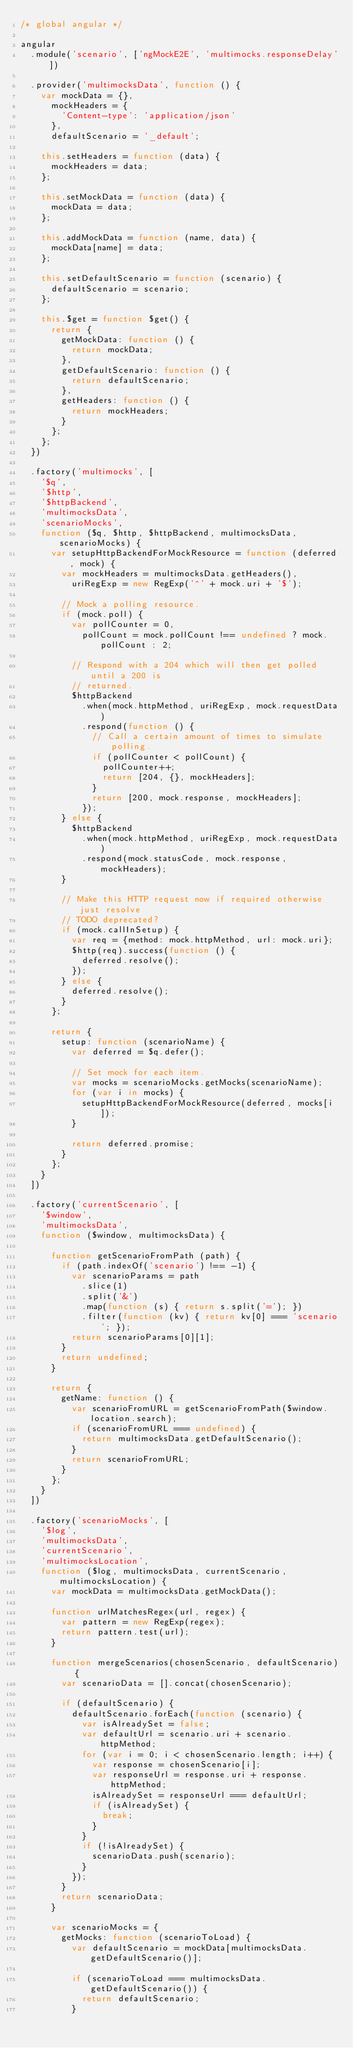<code> <loc_0><loc_0><loc_500><loc_500><_JavaScript_>/* global angular */

angular
  .module('scenario', ['ngMockE2E', 'multimocks.responseDelay'])

  .provider('multimocksData', function () {
    var mockData = {},
      mockHeaders = {
        'Content-type': 'application/json'
      },
      defaultScenario = '_default';

    this.setHeaders = function (data) {
      mockHeaders = data;
    };

    this.setMockData = function (data) {
      mockData = data;
    };

    this.addMockData = function (name, data) {
      mockData[name] = data;
    };

    this.setDefaultScenario = function (scenario) {
      defaultScenario = scenario;
    };

    this.$get = function $get() {
      return {
        getMockData: function () {
          return mockData;
        },
        getDefaultScenario: function () {
          return defaultScenario;
        },
        getHeaders: function () {
          return mockHeaders;
        }
      };
    };
  })

  .factory('multimocks', [
    '$q',
    '$http',
    '$httpBackend',
    'multimocksData',
    'scenarioMocks',
    function ($q, $http, $httpBackend, multimocksData, scenarioMocks) {
      var setupHttpBackendForMockResource = function (deferred, mock) {
        var mockHeaders = multimocksData.getHeaders(),
          uriRegExp = new RegExp('^' + mock.uri + '$');

        // Mock a polling resource.
        if (mock.poll) {
          var pollCounter = 0,
            pollCount = mock.pollCount !== undefined ? mock.pollCount : 2;

          // Respond with a 204 which will then get polled until a 200 is
          // returned.
          $httpBackend
            .when(mock.httpMethod, uriRegExp, mock.requestData)
            .respond(function () {
              // Call a certain amount of times to simulate polling.
              if (pollCounter < pollCount) {
                pollCounter++;
                return [204, {}, mockHeaders];
              }
              return [200, mock.response, mockHeaders];
            });
        } else {
          $httpBackend
            .when(mock.httpMethod, uriRegExp, mock.requestData)
            .respond(mock.statusCode, mock.response, mockHeaders);
        }

        // Make this HTTP request now if required otherwise just resolve
        // TODO deprecated?
        if (mock.callInSetup) {
          var req = {method: mock.httpMethod, url: mock.uri};
          $http(req).success(function () {
            deferred.resolve();
          });
        } else {
          deferred.resolve();
        }
      };

      return {
        setup: function (scenarioName) {
          var deferred = $q.defer();

          // Set mock for each item.
          var mocks = scenarioMocks.getMocks(scenarioName);
          for (var i in mocks) {
            setupHttpBackendForMockResource(deferred, mocks[i]);
          }

          return deferred.promise;
        }
      };
    }
  ])

  .factory('currentScenario', [
    '$window',
    'multimocksData',
    function ($window, multimocksData) {

      function getScenarioFromPath (path) {
        if (path.indexOf('scenario') !== -1) {
          var scenarioParams = path
            .slice(1)
            .split('&')
            .map(function (s) { return s.split('='); })
            .filter(function (kv) { return kv[0] === 'scenario'; });
          return scenarioParams[0][1];
        }
        return undefined;
      }

      return {
        getName: function () {
          var scenarioFromURL = getScenarioFromPath($window.location.search);
          if (scenarioFromURL === undefined) {
            return multimocksData.getDefaultScenario();
          }
          return scenarioFromURL;
        }
      };
    }
  ])

  .factory('scenarioMocks', [
    '$log',
    'multimocksData',
    'currentScenario',
    'multimocksLocation',
    function ($log, multimocksData, currentScenario, multimocksLocation) {
      var mockData = multimocksData.getMockData();

      function urlMatchesRegex(url, regex) {
        var pattern = new RegExp(regex);
        return pattern.test(url);
      }

      function mergeScenarios(chosenScenario, defaultScenario) {
        var scenarioData = [].concat(chosenScenario);

        if (defaultScenario) {
          defaultScenario.forEach(function (scenario) {
            var isAlreadySet = false;
            var defaultUrl = scenario.uri + scenario.httpMethod;
            for (var i = 0; i < chosenScenario.length; i++) {
              var response = chosenScenario[i];
              var responseUrl = response.uri + response.httpMethod;
              isAlreadySet = responseUrl === defaultUrl;
              if (isAlreadySet) {
                break;
              }
            }
            if (!isAlreadySet) {
              scenarioData.push(scenario);
            }
          });
        }
        return scenarioData;
      }

      var scenarioMocks = {
        getMocks: function (scenarioToLoad) {
          var defaultScenario = mockData[multimocksData.getDefaultScenario()];

          if (scenarioToLoad === multimocksData.getDefaultScenario()) {
            return defaultScenario;
          }
</code> 